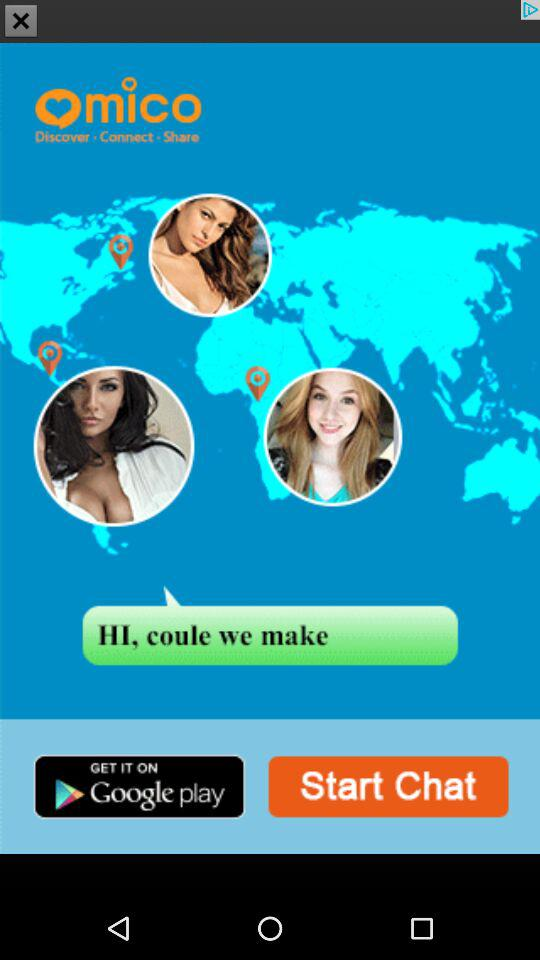How many women are pictured in the screenshot?
Answer the question using a single word or phrase. 3 